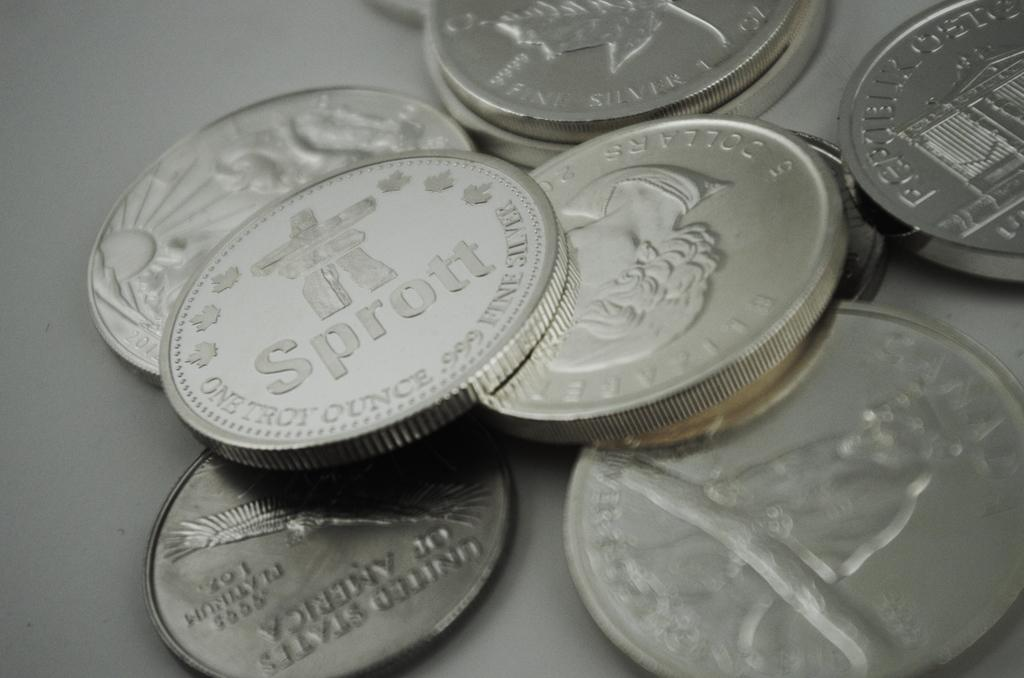<image>
Summarize the visual content of the image. Silver coins stacked on top of each other one says Sprott 